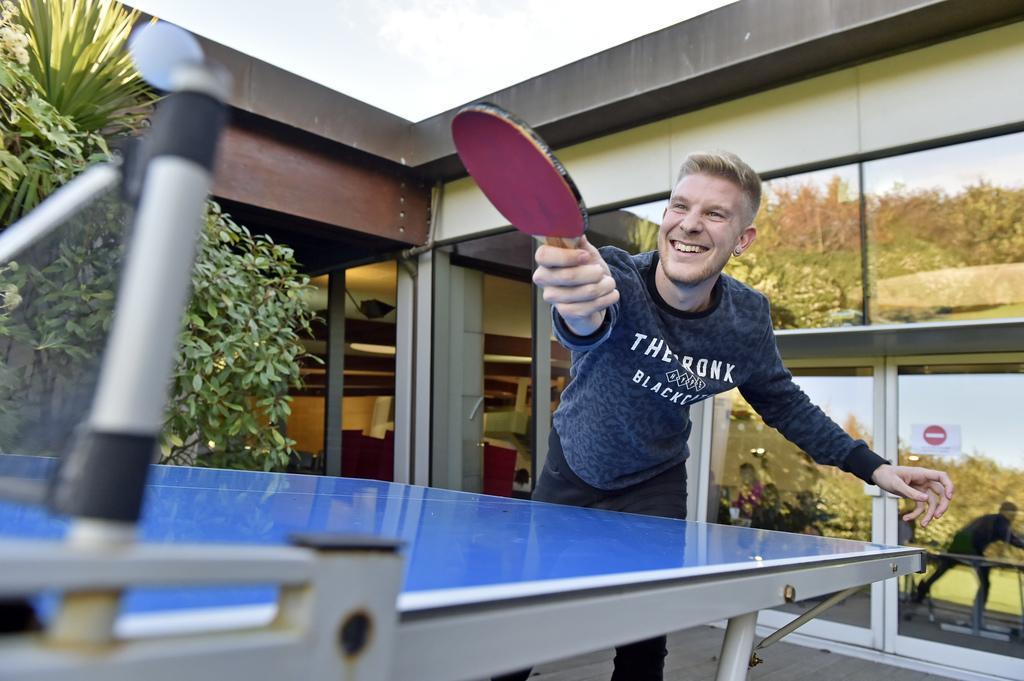Can you describe this image briefly? In this picture there is a man playing table tennis and holding a bat and we can see table, net and ball. We can see trees. In the background we can see glass doors, wall, poster and glass windows. 